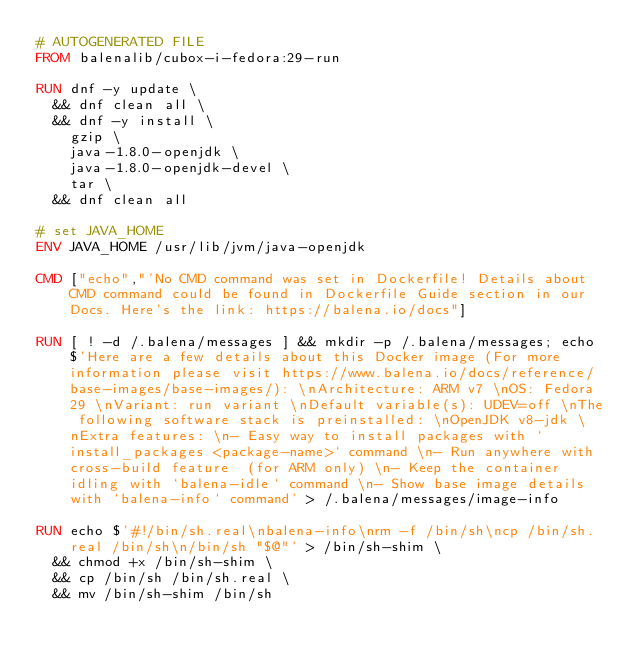<code> <loc_0><loc_0><loc_500><loc_500><_Dockerfile_># AUTOGENERATED FILE
FROM balenalib/cubox-i-fedora:29-run

RUN dnf -y update \
	&& dnf clean all \
	&& dnf -y install \
		gzip \
		java-1.8.0-openjdk \
		java-1.8.0-openjdk-devel \
		tar \
	&& dnf clean all

# set JAVA_HOME
ENV JAVA_HOME /usr/lib/jvm/java-openjdk

CMD ["echo","'No CMD command was set in Dockerfile! Details about CMD command could be found in Dockerfile Guide section in our Docs. Here's the link: https://balena.io/docs"]

RUN [ ! -d /.balena/messages ] && mkdir -p /.balena/messages; echo $'Here are a few details about this Docker image (For more information please visit https://www.balena.io/docs/reference/base-images/base-images/): \nArchitecture: ARM v7 \nOS: Fedora 29 \nVariant: run variant \nDefault variable(s): UDEV=off \nThe following software stack is preinstalled: \nOpenJDK v8-jdk \nExtra features: \n- Easy way to install packages with `install_packages <package-name>` command \n- Run anywhere with cross-build feature  (for ARM only) \n- Keep the container idling with `balena-idle` command \n- Show base image details with `balena-info` command' > /.balena/messages/image-info

RUN echo $'#!/bin/sh.real\nbalena-info\nrm -f /bin/sh\ncp /bin/sh.real /bin/sh\n/bin/sh "$@"' > /bin/sh-shim \
	&& chmod +x /bin/sh-shim \
	&& cp /bin/sh /bin/sh.real \
	&& mv /bin/sh-shim /bin/sh</code> 